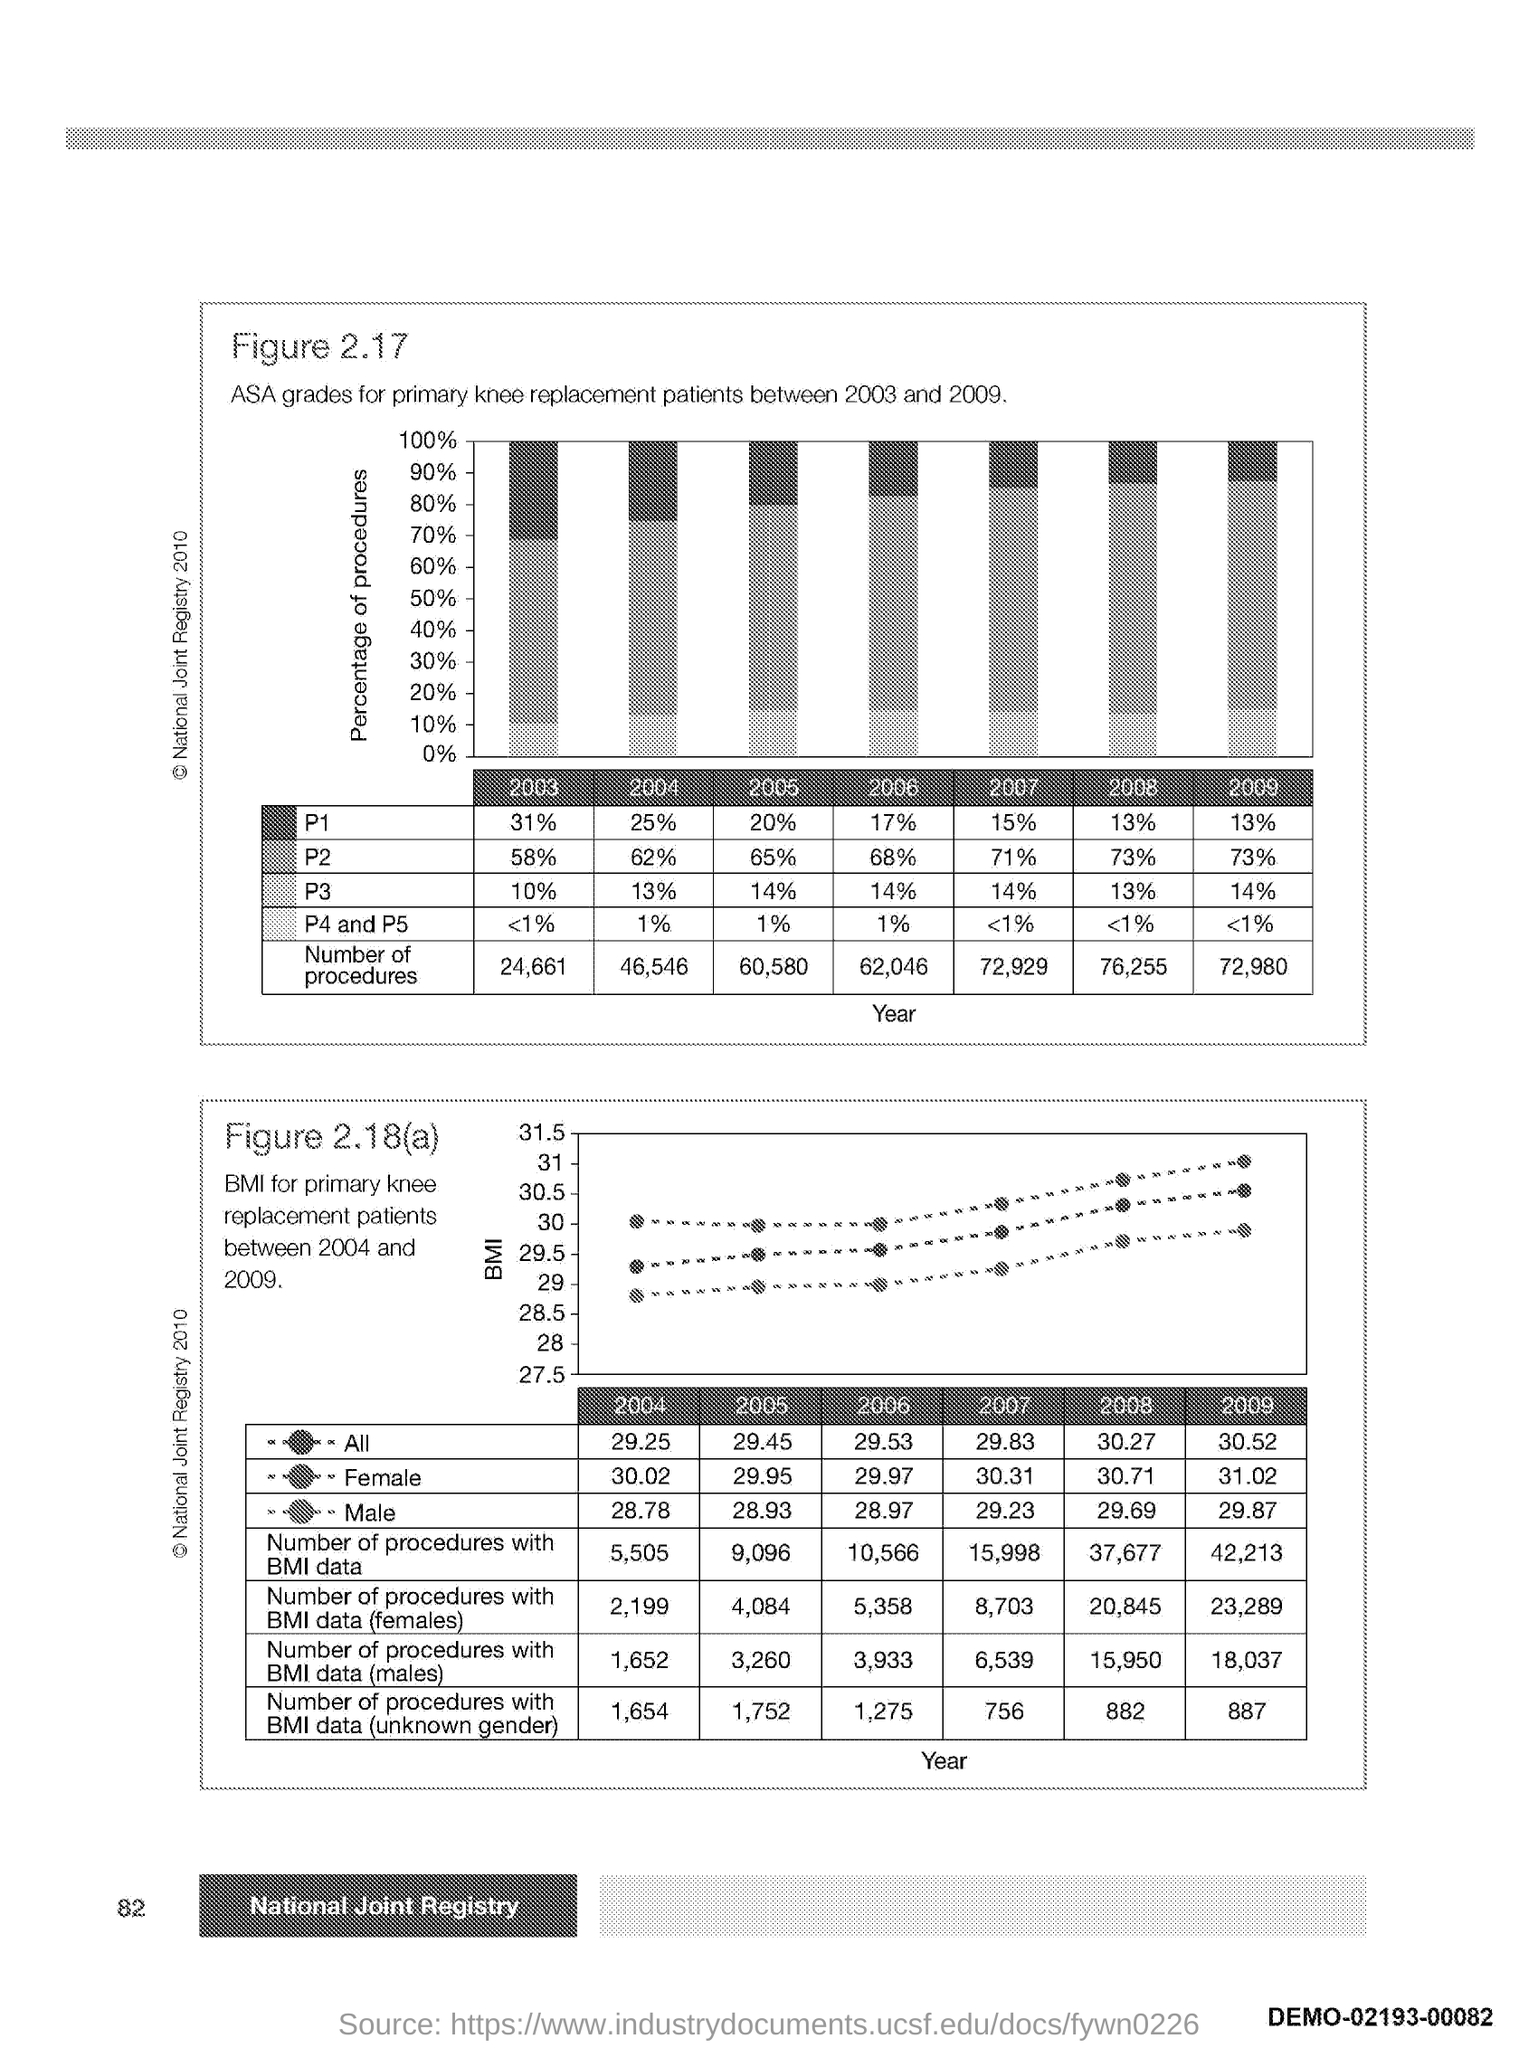Draw attention to some important aspects in this diagram. The number at the bottom left side of the page is 82. 